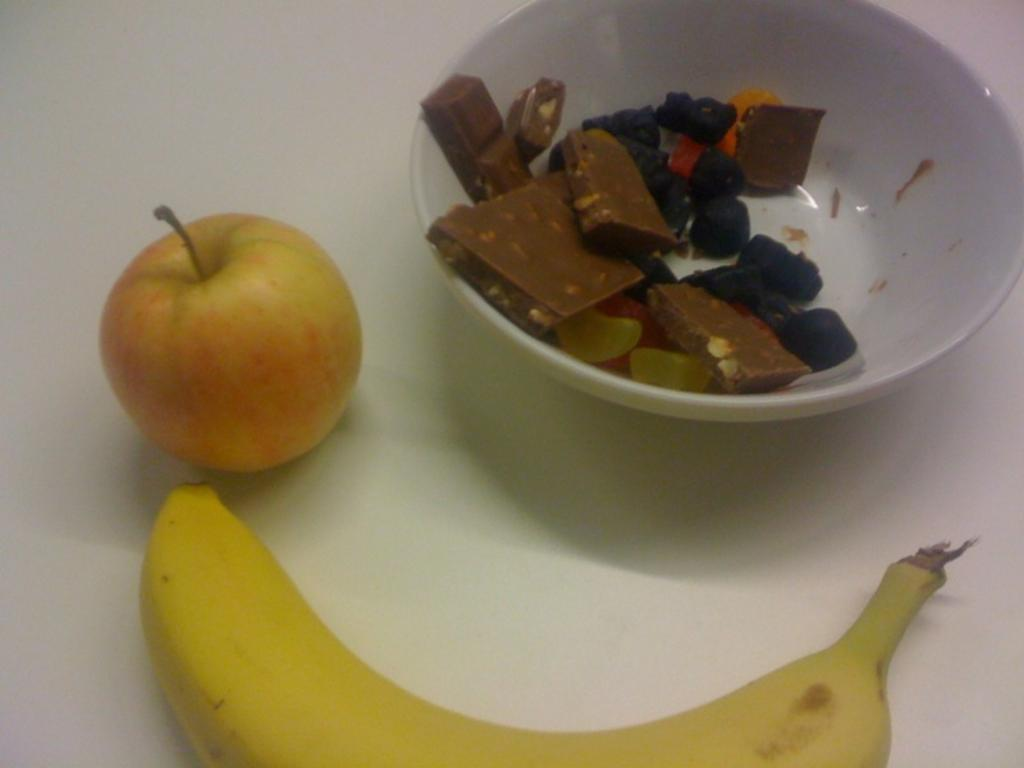What type of fruit is on the platform in the image? There is an apple and a banana on a platform in the image. What is in the bowl besides the chocolates? There are other food items in a bowl in the image. What type of iron can be seen in the image? There is no iron present in the image. Can you describe the squirrel sitting on the table in the image? There is no squirrel present in the image. 